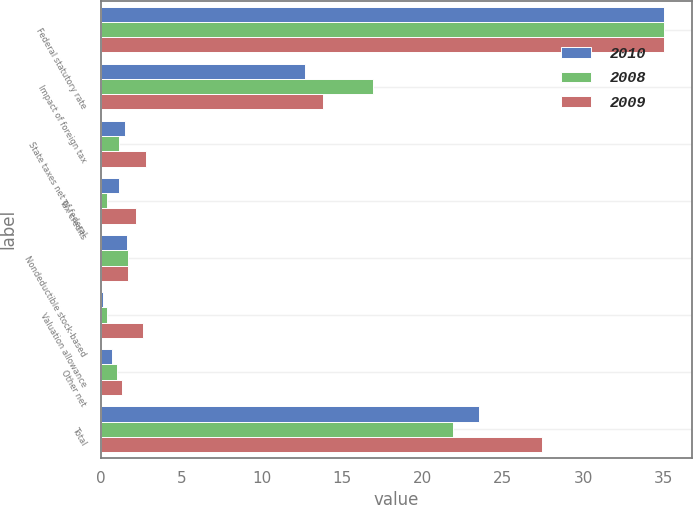Convert chart to OTSL. <chart><loc_0><loc_0><loc_500><loc_500><stacked_bar_chart><ecel><fcel>Federal statutory rate<fcel>Impact of foreign tax<fcel>State taxes net of federal<fcel>Tax credits<fcel>Nondeductible stock-based<fcel>Valuation allowance<fcel>Other net<fcel>Total<nl><fcel>2010<fcel>35<fcel>12.7<fcel>1.5<fcel>1.1<fcel>1.6<fcel>0.1<fcel>0.7<fcel>23.5<nl><fcel>2008<fcel>35<fcel>16.9<fcel>1.1<fcel>0.4<fcel>1.7<fcel>0.4<fcel>1<fcel>21.9<nl><fcel>2009<fcel>35<fcel>13.8<fcel>2.8<fcel>2.2<fcel>1.7<fcel>2.6<fcel>1.3<fcel>27.4<nl></chart> 